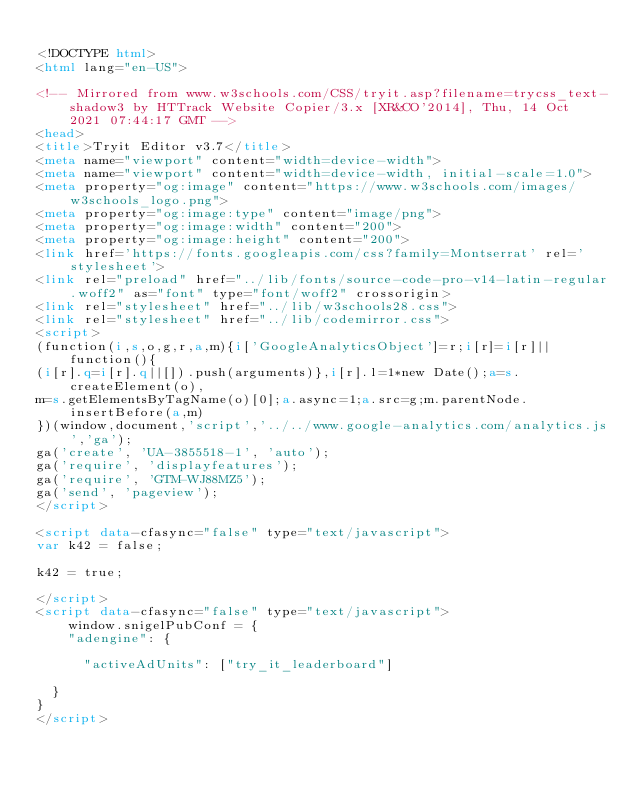Convert code to text. <code><loc_0><loc_0><loc_500><loc_500><_HTML_>
<!DOCTYPE html>
<html lang="en-US">

<!-- Mirrored from www.w3schools.com/CSS/tryit.asp?filename=trycss_text-shadow3 by HTTrack Website Copier/3.x [XR&CO'2014], Thu, 14 Oct 2021 07:44:17 GMT -->
<head>
<title>Tryit Editor v3.7</title>
<meta name="viewport" content="width=device-width">
<meta name="viewport" content="width=device-width, initial-scale=1.0">
<meta property="og:image" content="https://www.w3schools.com/images/w3schools_logo.png">
<meta property="og:image:type" content="image/png">
<meta property="og:image:width" content="200">
<meta property="og:image:height" content="200">
<link href='https://fonts.googleapis.com/css?family=Montserrat' rel='stylesheet'>
<link rel="preload" href="../lib/fonts/source-code-pro-v14-latin-regular.woff2" as="font" type="font/woff2" crossorigin>
<link rel="stylesheet" href="../lib/w3schools28.css">
<link rel="stylesheet" href="../lib/codemirror.css">
<script>
(function(i,s,o,g,r,a,m){i['GoogleAnalyticsObject']=r;i[r]=i[r]||function(){
(i[r].q=i[r].q||[]).push(arguments)},i[r].l=1*new Date();a=s.createElement(o),
m=s.getElementsByTagName(o)[0];a.async=1;a.src=g;m.parentNode.insertBefore(a,m)
})(window,document,'script','../../www.google-analytics.com/analytics.js','ga');
ga('create', 'UA-3855518-1', 'auto');
ga('require', 'displayfeatures');
ga('require', 'GTM-WJ88MZ5');
ga('send', 'pageview');
</script>

<script data-cfasync="false" type="text/javascript">
var k42 = false;

k42 = true;

</script>
<script data-cfasync="false" type="text/javascript">
    window.snigelPubConf = {
    "adengine": {

      "activeAdUnits": ["try_it_leaderboard"]

  }
}
</script></code> 